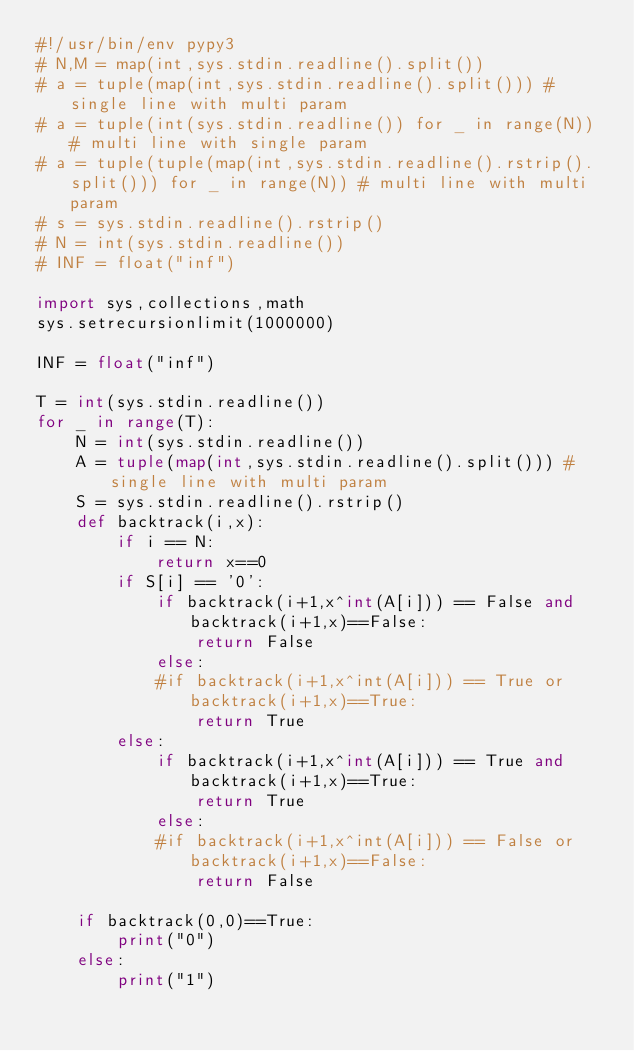Convert code to text. <code><loc_0><loc_0><loc_500><loc_500><_Python_>#!/usr/bin/env pypy3
# N,M = map(int,sys.stdin.readline().split())
# a = tuple(map(int,sys.stdin.readline().split())) # single line with multi param
# a = tuple(int(sys.stdin.readline()) for _ in range(N)) # multi line with single param
# a = tuple(tuple(map(int,sys.stdin.readline().rstrip().split())) for _ in range(N)) # multi line with multi param
# s = sys.stdin.readline().rstrip()
# N = int(sys.stdin.readline())
# INF = float("inf")

import sys,collections,math
sys.setrecursionlimit(1000000)

INF = float("inf")

T = int(sys.stdin.readline())
for _ in range(T):
    N = int(sys.stdin.readline())
    A = tuple(map(int,sys.stdin.readline().split())) # single line with multi param
    S = sys.stdin.readline().rstrip()
    def backtrack(i,x):
        if i == N:
            return x==0
        if S[i] == '0':
            if backtrack(i+1,x^int(A[i])) == False and backtrack(i+1,x)==False:
                return False
            else:
            #if backtrack(i+1,x^int(A[i])) == True or backtrack(i+1,x)==True:
                return True
        else:
            if backtrack(i+1,x^int(A[i])) == True and backtrack(i+1,x)==True:
                return True
            else:
            #if backtrack(i+1,x^int(A[i])) == False or backtrack(i+1,x)==False:
                return False

    if backtrack(0,0)==True:
        print("0")
    else:
        print("1")</code> 